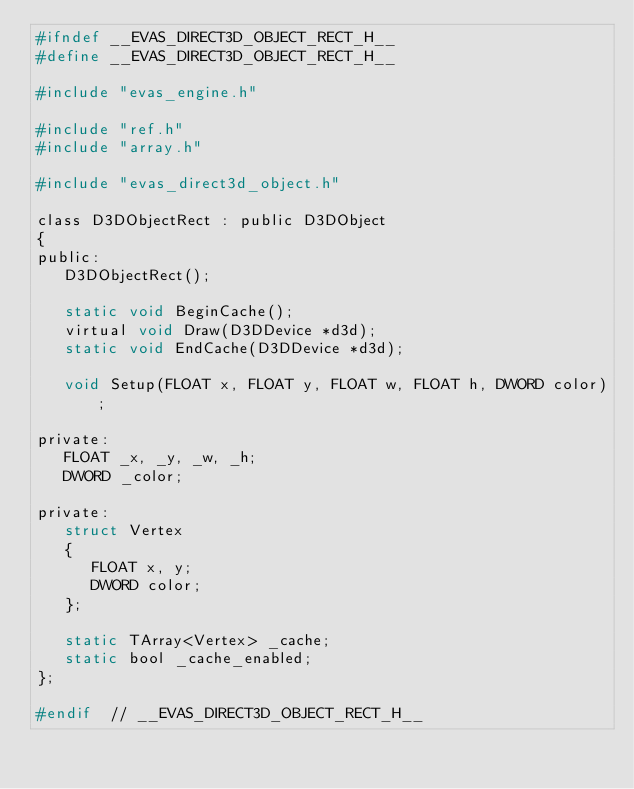<code> <loc_0><loc_0><loc_500><loc_500><_C_>#ifndef __EVAS_DIRECT3D_OBJECT_RECT_H__
#define __EVAS_DIRECT3D_OBJECT_RECT_H__

#include "evas_engine.h"

#include "ref.h"
#include "array.h"

#include "evas_direct3d_object.h"

class D3DObjectRect : public D3DObject
{
public:
   D3DObjectRect();

   static void BeginCache();
   virtual void Draw(D3DDevice *d3d);
   static void EndCache(D3DDevice *d3d);

   void Setup(FLOAT x, FLOAT y, FLOAT w, FLOAT h, DWORD color);

private:
   FLOAT _x, _y, _w, _h;
   DWORD _color;

private:
   struct Vertex
   {
      FLOAT x, y;
      DWORD color;
   };

   static TArray<Vertex> _cache;
   static bool _cache_enabled;
};

#endif  // __EVAS_DIRECT3D_OBJECT_RECT_H__
</code> 